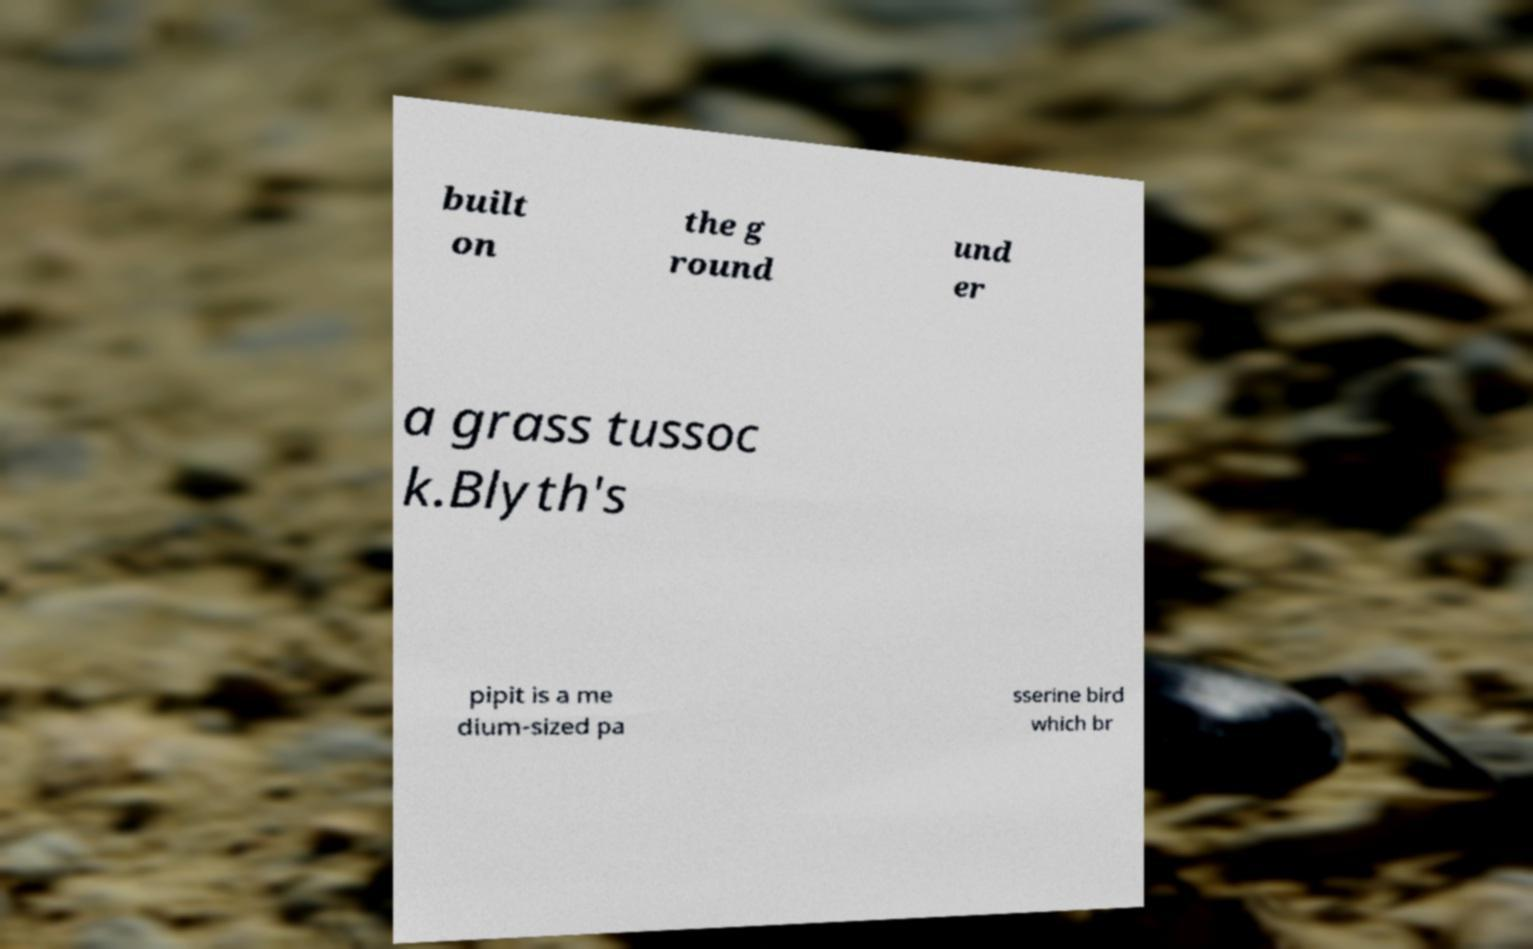Please identify and transcribe the text found in this image. built on the g round und er a grass tussoc k.Blyth's pipit is a me dium-sized pa sserine bird which br 